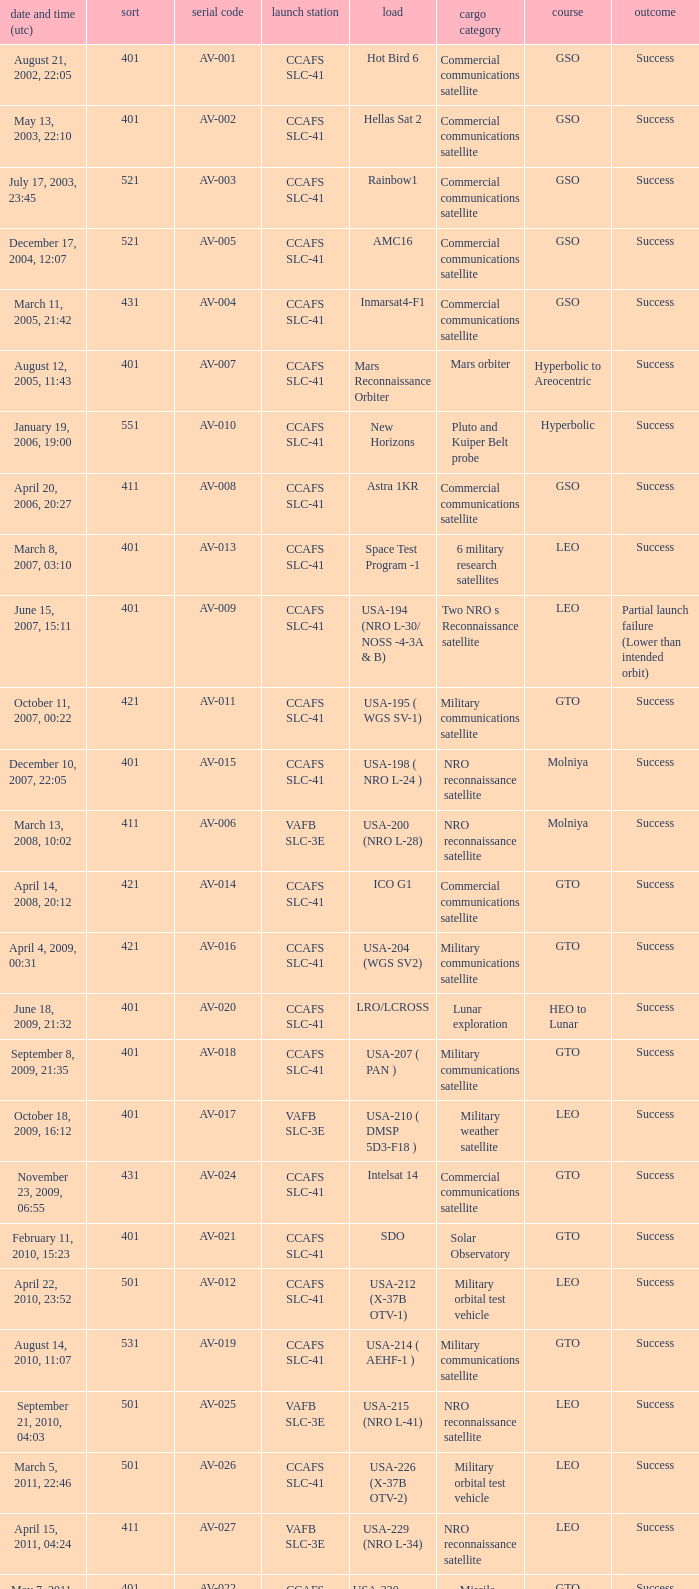What payload was on November 26, 2011, 15:02? Mars rover. 